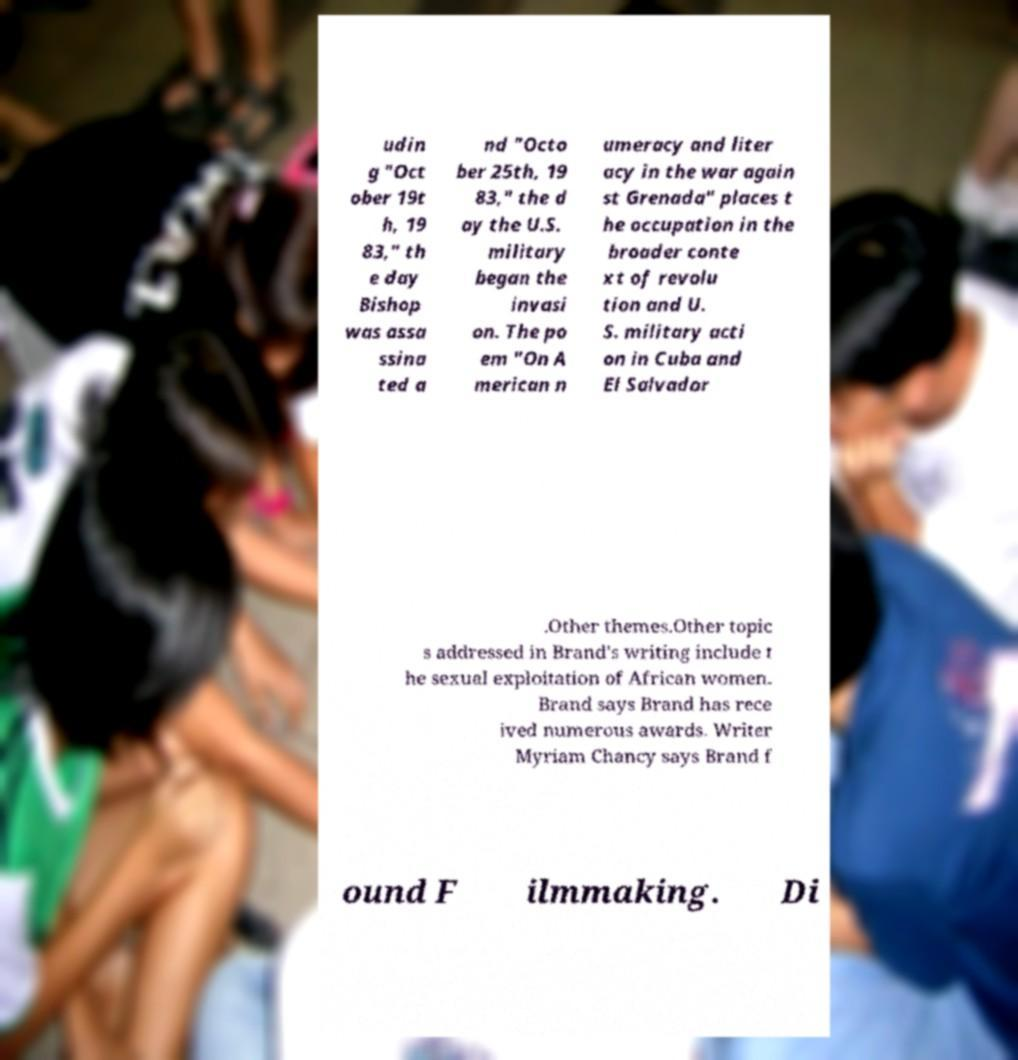There's text embedded in this image that I need extracted. Can you transcribe it verbatim? udin g "Oct ober 19t h, 19 83," th e day Bishop was assa ssina ted a nd "Octo ber 25th, 19 83," the d ay the U.S. military began the invasi on. The po em "On A merican n umeracy and liter acy in the war again st Grenada" places t he occupation in the broader conte xt of revolu tion and U. S. military acti on in Cuba and El Salvador .Other themes.Other topic s addressed in Brand's writing include t he sexual exploitation of African women. Brand says Brand has rece ived numerous awards. Writer Myriam Chancy says Brand f ound F ilmmaking. Di 